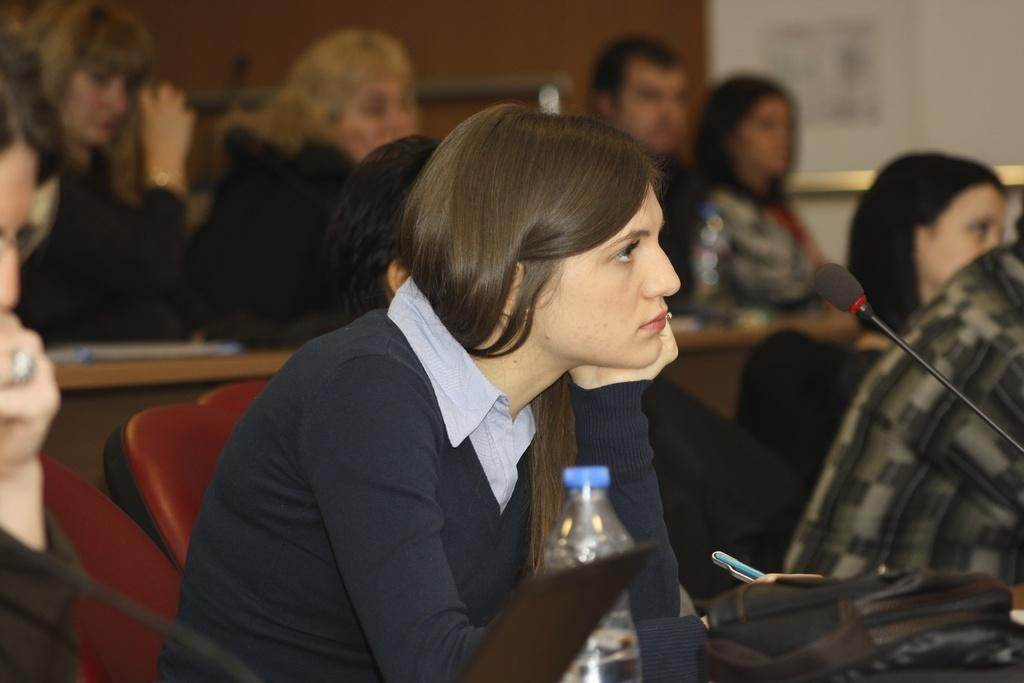What are the people in the image doing? Each person in the image is sitting on a chair. What is in front of the woman? There is a table in front of the woman. What items can be seen on the table? There is a bag, a bottle, and a laptop on the table. What is the woman wearing? The woman is wearing a blue t-shirt. What is the woman holding? The woman is holding pens. What additional object can be seen in the image? There is a microphone (mic) in the image. Can you see a lamp on the table in the image? No, there is no lamp present on the table in the image. Is there a ship visible in the background of the image? No, there is no ship visible in the image. 